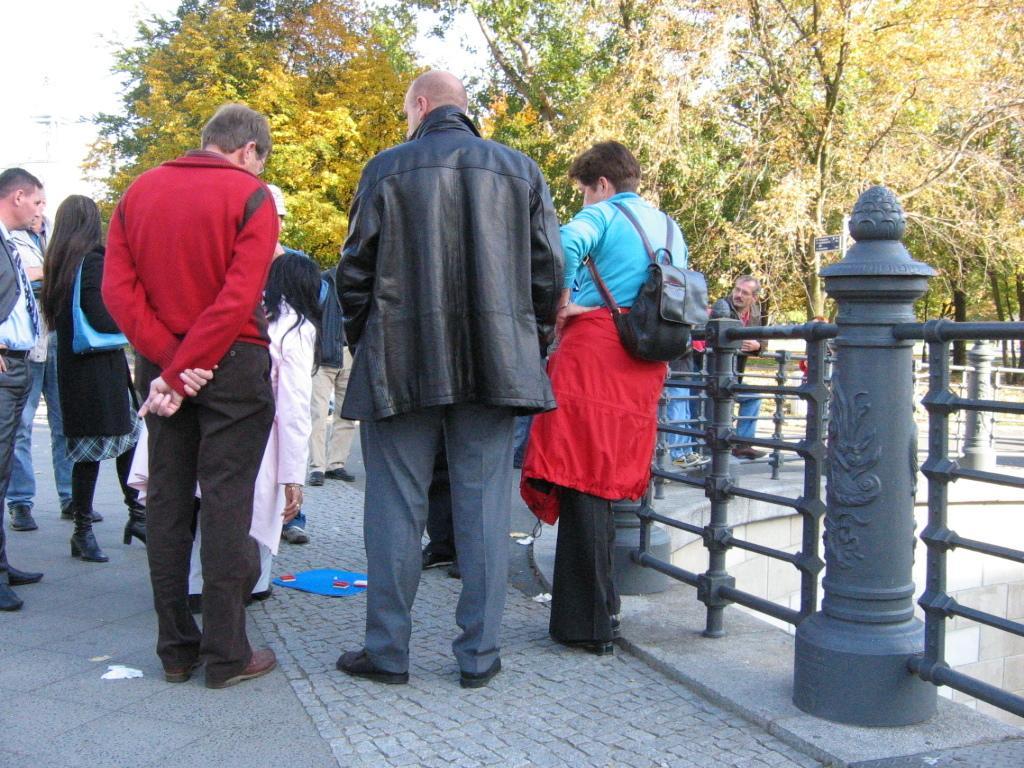How would you summarize this image in a sentence or two? In the center of the image there are people standing. On the right there is a railing. In the background there are trees and sky. 